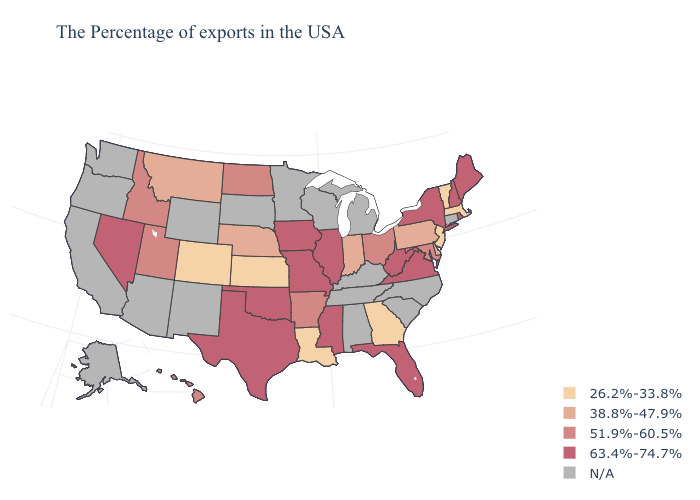Which states have the lowest value in the USA?
Give a very brief answer. Massachusetts, Vermont, New Jersey, Georgia, Louisiana, Kansas, Colorado. Which states have the lowest value in the USA?
Short answer required. Massachusetts, Vermont, New Jersey, Georgia, Louisiana, Kansas, Colorado. Does the map have missing data?
Answer briefly. Yes. Among the states that border California , which have the highest value?
Quick response, please. Nevada. Name the states that have a value in the range 63.4%-74.7%?
Keep it brief. Maine, Rhode Island, New Hampshire, New York, Virginia, West Virginia, Florida, Illinois, Mississippi, Missouri, Iowa, Oklahoma, Texas, Nevada. What is the lowest value in the South?
Short answer required. 26.2%-33.8%. What is the value of Massachusetts?
Keep it brief. 26.2%-33.8%. What is the value of Connecticut?
Keep it brief. N/A. What is the lowest value in the West?
Quick response, please. 26.2%-33.8%. What is the highest value in the Northeast ?
Quick response, please. 63.4%-74.7%. Among the states that border South Dakota , does Nebraska have the lowest value?
Be succinct. Yes. What is the value of Mississippi?
Answer briefly. 63.4%-74.7%. What is the value of Arizona?
Give a very brief answer. N/A. 